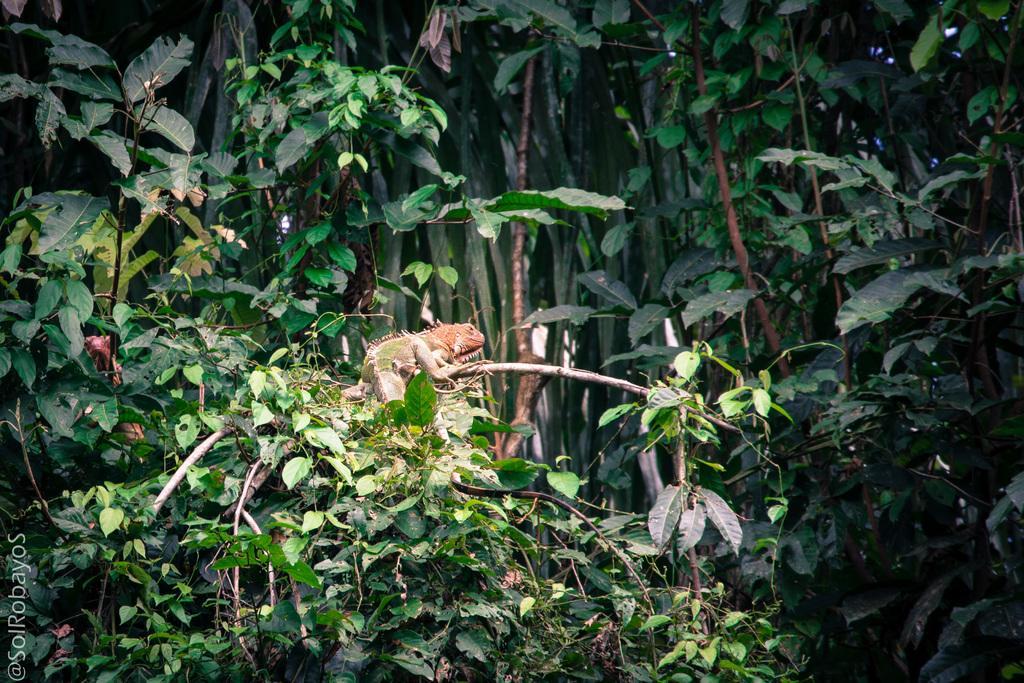Can you describe this image briefly? In the image there are a lot of plants and there is a reptile on one of the branch of the plants. 